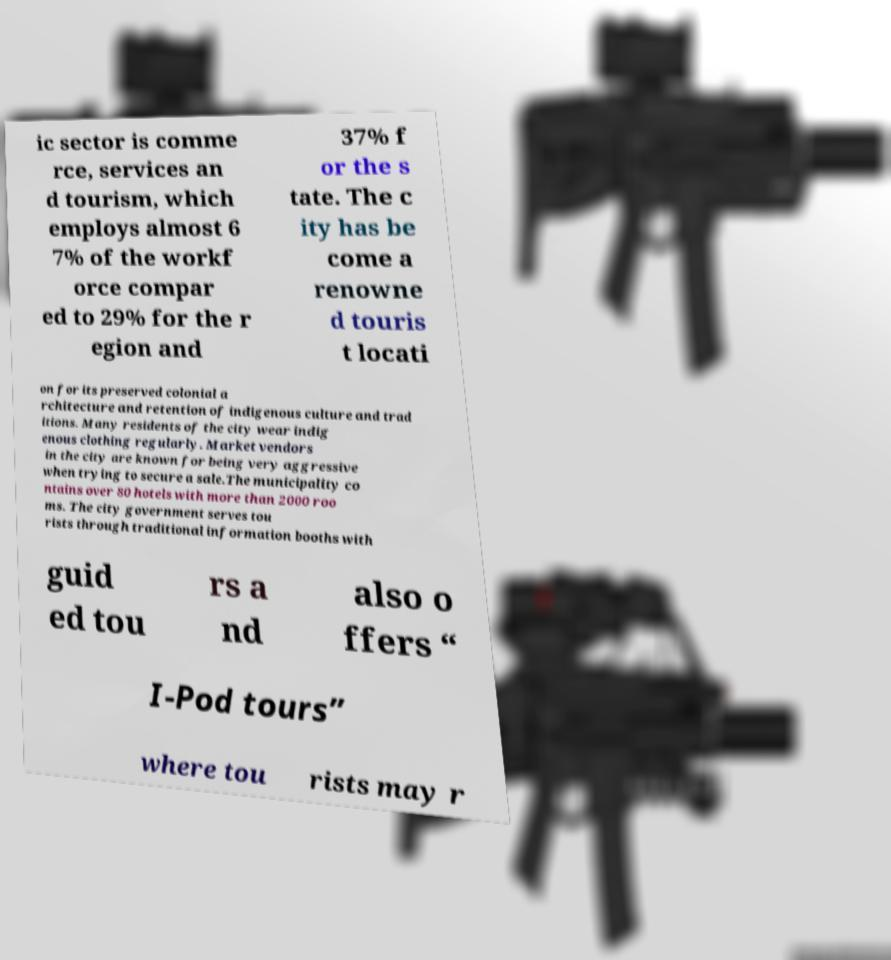Can you accurately transcribe the text from the provided image for me? ic sector is comme rce, services an d tourism, which employs almost 6 7% of the workf orce compar ed to 29% for the r egion and 37% f or the s tate. The c ity has be come a renowne d touris t locati on for its preserved colonial a rchitecture and retention of indigenous culture and trad itions. Many residents of the city wear indig enous clothing regularly. Market vendors in the city are known for being very aggressive when trying to secure a sale.The municipality co ntains over 80 hotels with more than 2000 roo ms. The city government serves tou rists through traditional information booths with guid ed tou rs a nd also o ffers “ I-Pod tours” where tou rists may r 